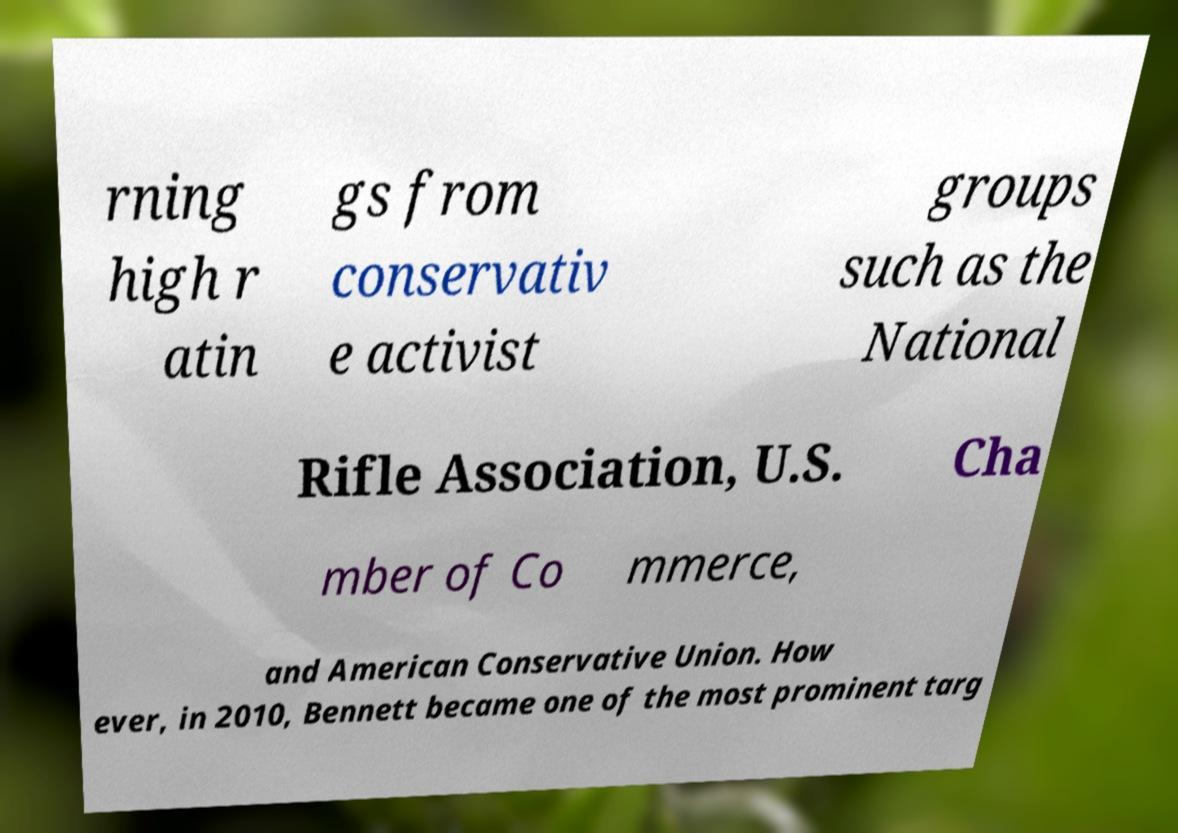Please read and relay the text visible in this image. What does it say? rning high r atin gs from conservativ e activist groups such as the National Rifle Association, U.S. Cha mber of Co mmerce, and American Conservative Union. How ever, in 2010, Bennett became one of the most prominent targ 